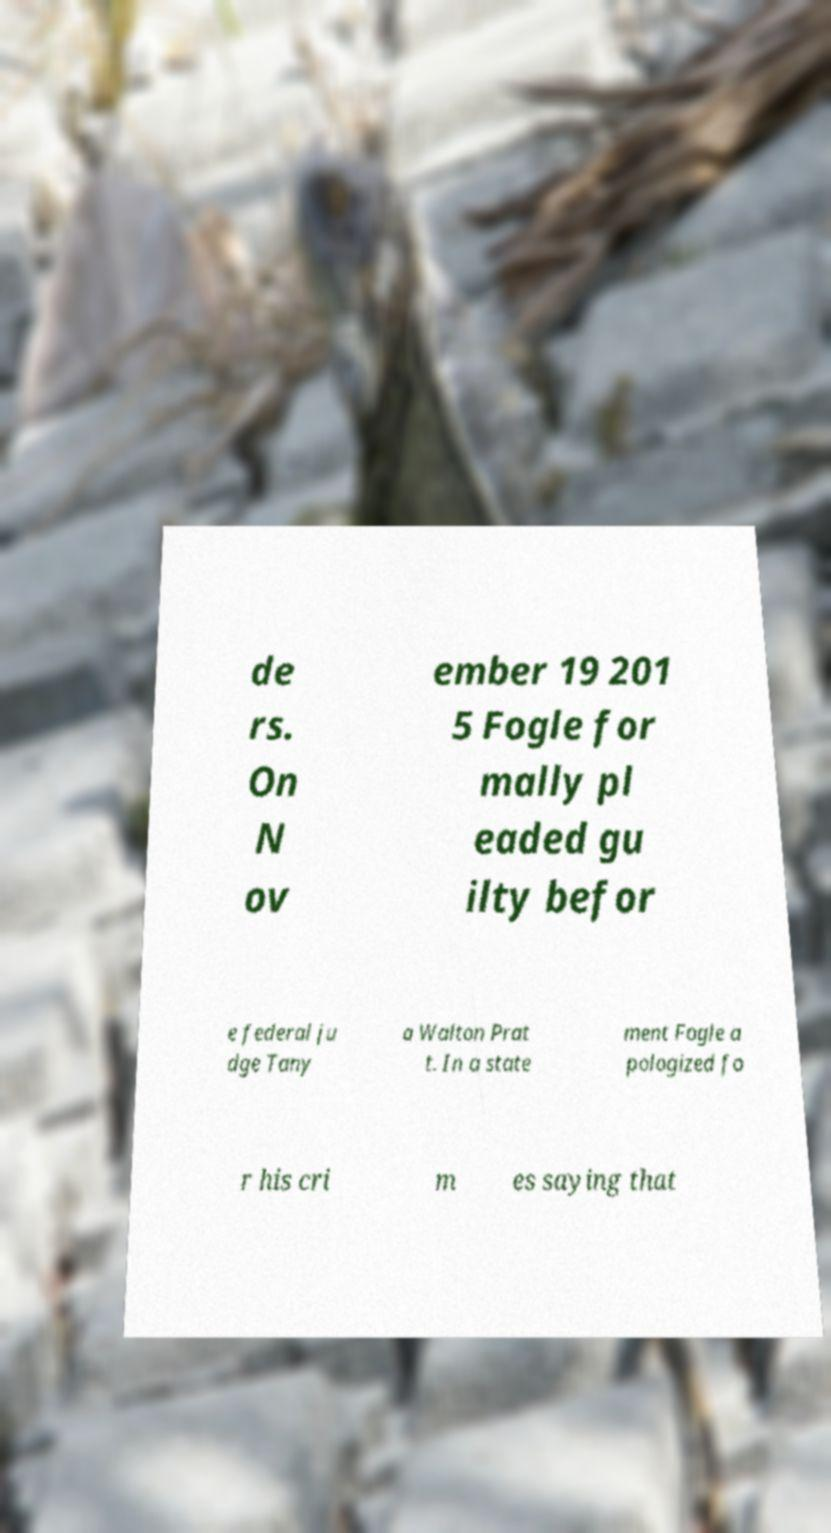Please identify and transcribe the text found in this image. de rs. On N ov ember 19 201 5 Fogle for mally pl eaded gu ilty befor e federal ju dge Tany a Walton Prat t. In a state ment Fogle a pologized fo r his cri m es saying that 